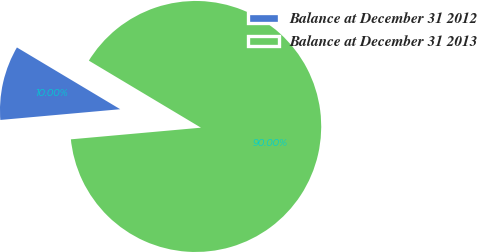Convert chart to OTSL. <chart><loc_0><loc_0><loc_500><loc_500><pie_chart><fcel>Balance at December 31 2012<fcel>Balance at December 31 2013<nl><fcel>10.0%<fcel>90.0%<nl></chart> 